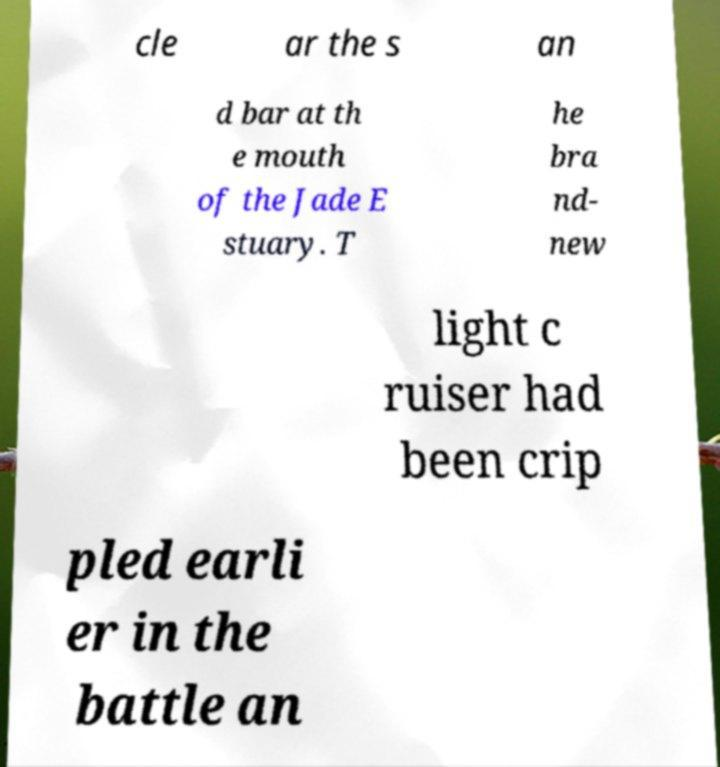Could you extract and type out the text from this image? cle ar the s an d bar at th e mouth of the Jade E stuary. T he bra nd- new light c ruiser had been crip pled earli er in the battle an 